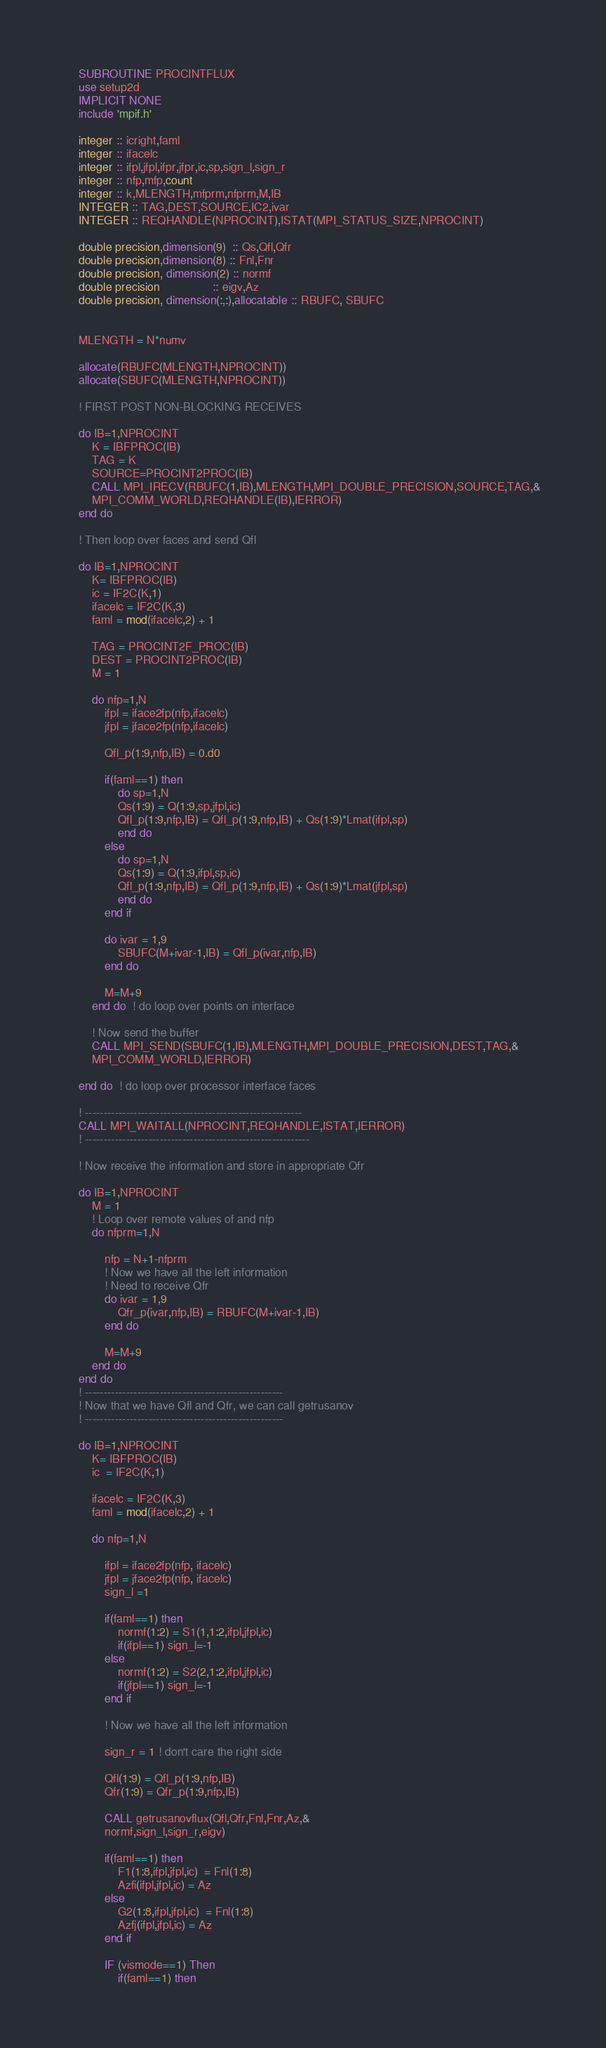<code> <loc_0><loc_0><loc_500><loc_500><_FORTRAN_>    SUBROUTINE PROCINTFLUX
    use setup2d
    IMPLICIT NONE
    include 'mpif.h'
  
    integer :: icright,faml
    integer :: ifacelc
    integer :: ifpl,jfpl,ifpr,jfpr,ic,sp,sign_l,sign_r
    integer :: nfp,mfp,count
    integer :: k,MLENGTH,mfprm,nfprm,M,IB
    INTEGER :: TAG,DEST,SOURCE,IC2,ivar
    INTEGER :: REQHANDLE(NPROCINT),ISTAT(MPI_STATUS_SIZE,NPROCINT)
  
    double precision,dimension(9)  :: Qs,Qfl,Qfr
    double precision,dimension(8) :: Fnl,Fnr
    double precision, dimension(2) :: normf
    double precision                :: eigv,Az
    double precision, dimension(:,:),allocatable :: RBUFC, SBUFC
  
  
    MLENGTH = N*numv
  
    allocate(RBUFC(MLENGTH,NPROCINT))
    allocate(SBUFC(MLENGTH,NPROCINT))
  
    ! FIRST POST NON-BLOCKING RECEIVES
  
    do IB=1,NPROCINT
        K = IBFPROC(IB)
        TAG = K
        SOURCE=PROCINT2PROC(IB)
        CALL MPI_IRECV(RBUFC(1,IB),MLENGTH,MPI_DOUBLE_PRECISION,SOURCE,TAG,&
        MPI_COMM_WORLD,REQHANDLE(IB),IERROR)
    end do
  
    ! Then loop over faces and send Qfl
  
    do IB=1,NPROCINT
        K= IBFPROC(IB)
        ic = IF2C(K,1)
        ifacelc = IF2C(K,3)
        faml = mod(ifacelc,2) + 1
  
        TAG = PROCINT2F_PROC(IB)
        DEST = PROCINT2PROC(IB)
        M = 1
  
        do nfp=1,N
            ifpl = iface2fp(nfp,ifacelc)
            jfpl = jface2fp(nfp,ifacelc)
   
            Qfl_p(1:9,nfp,IB) = 0.d0
  
            if(faml==1) then
                do sp=1,N
                Qs(1:9) = Q(1:9,sp,jfpl,ic)
                Qfl_p(1:9,nfp,IB) = Qfl_p(1:9,nfp,IB) + Qs(1:9)*Lmat(ifpl,sp)
                end do
            else
                do sp=1,N
                Qs(1:9) = Q(1:9,ifpl,sp,ic)
                Qfl_p(1:9,nfp,IB) = Qfl_p(1:9,nfp,IB) + Qs(1:9)*Lmat(jfpl,sp)
                end do
            end if

            do ivar = 1,9
                SBUFC(M+ivar-1,IB) = Qfl_p(ivar,nfp,IB)
            end do
  
            M=M+9
        end do  ! do loop over points on interface
  
        ! Now send the buffer
        CALL MPI_SEND(SBUFC(1,IB),MLENGTH,MPI_DOUBLE_PRECISION,DEST,TAG,&
        MPI_COMM_WORLD,IERROR)
  
    end do  ! do loop over processor interface faces
  
    ! ----------------------------------------------------------
    CALL MPI_WAITALL(NPROCINT,REQHANDLE,ISTAT,IERROR)
    ! ------------------------------------------------------------
    
    ! Now receive the information and store in appropriate Qfr
  
    do IB=1,NPROCINT
        M = 1
        ! Loop over remote values of and nfp
        do nfprm=1,N
  
            nfp = N+1-nfprm
            ! Now we have all the left information
            ! Need to receive Qfr
            do ivar = 1,9
                Qfr_p(ivar,nfp,IB) = RBUFC(M+ivar-1,IB)
            end do
  
            M=M+9
        end do
    end do
    ! -----------------------------------------------------
    ! Now that we have Qfl and Qfr, we can call getrusanov
    ! -----------------------------------------------------
  
    do IB=1,NPROCINT
        K= IBFPROC(IB)
        ic  = IF2C(K,1)
  
        ifacelc = IF2C(K,3)
        faml = mod(ifacelc,2) + 1
  
        do nfp=1,N
  
            ifpl = iface2fp(nfp, ifacelc)
            jfpl = jface2fp(nfp, ifacelc)  
            sign_l =1
  
            if(faml==1) then
                normf(1:2) = S1(1,1:2,ifpl,jfpl,ic)
                if(ifpl==1) sign_l=-1
            else
                normf(1:2) = S2(2,1:2,ifpl,jfpl,ic)
                if(jfpl==1) sign_l=-1
            end if
  
            ! Now we have all the left information
  
            sign_r = 1 ! don't care the right side

            Qfl(1:9) = Qfl_p(1:9,nfp,IB)
            Qfr(1:9) = Qfr_p(1:9,nfp,IB)
  
            CALL getrusanovflux(Qfl,Qfr,Fnl,Fnr,Az,&
            normf,sign_l,sign_r,eigv)
  
            if(faml==1) then
                F1(1:8,ifpl,jfpl,ic)  = Fnl(1:8)
                Azfi(ifpl,jfpl,ic) = Az
            else
                G2(1:8,ifpl,jfpl,ic)  = Fnl(1:8)
                Azfj(ifpl,jfpl,ic) = Az
            end if
  
            IF (vismode==1) Then
                if(faml==1) then</code> 